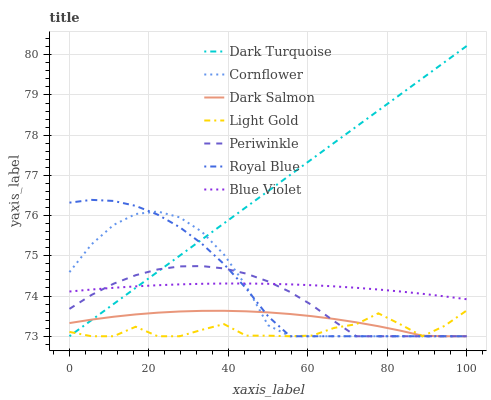Does Light Gold have the minimum area under the curve?
Answer yes or no. Yes. Does Dark Turquoise have the maximum area under the curve?
Answer yes or no. Yes. Does Dark Salmon have the minimum area under the curve?
Answer yes or no. No. Does Dark Salmon have the maximum area under the curve?
Answer yes or no. No. Is Dark Turquoise the smoothest?
Answer yes or no. Yes. Is Light Gold the roughest?
Answer yes or no. Yes. Is Dark Salmon the smoothest?
Answer yes or no. No. Is Dark Salmon the roughest?
Answer yes or no. No. Does Cornflower have the lowest value?
Answer yes or no. Yes. Does Blue Violet have the lowest value?
Answer yes or no. No. Does Dark Turquoise have the highest value?
Answer yes or no. Yes. Does Dark Salmon have the highest value?
Answer yes or no. No. Is Light Gold less than Blue Violet?
Answer yes or no. Yes. Is Blue Violet greater than Light Gold?
Answer yes or no. Yes. Does Periwinkle intersect Dark Turquoise?
Answer yes or no. Yes. Is Periwinkle less than Dark Turquoise?
Answer yes or no. No. Is Periwinkle greater than Dark Turquoise?
Answer yes or no. No. Does Light Gold intersect Blue Violet?
Answer yes or no. No. 